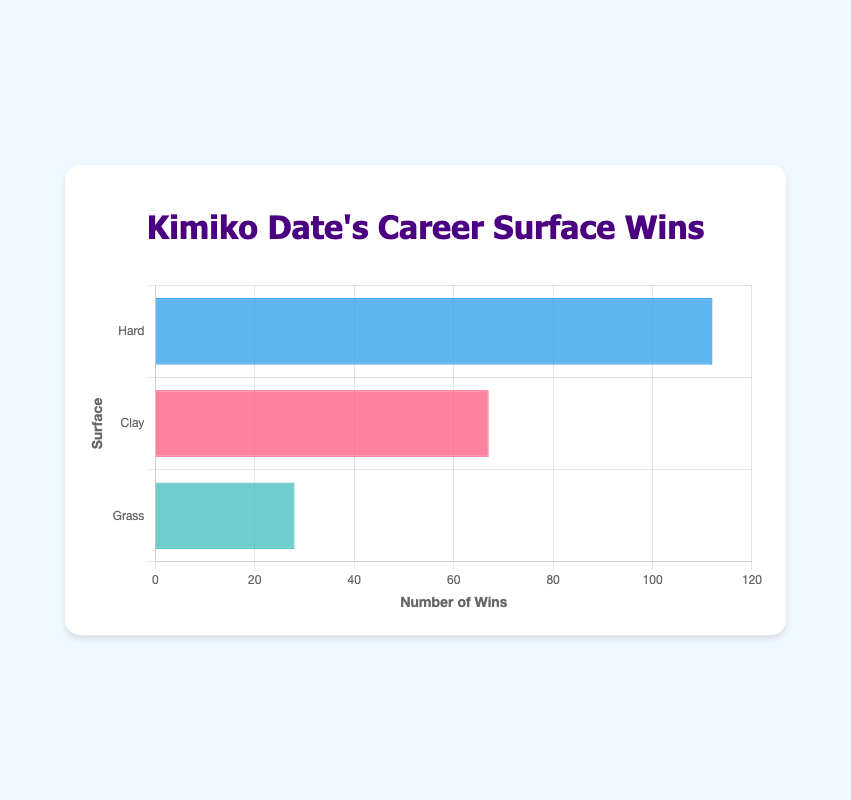What is the total number of wins across all surfaces? To find the total number of wins, add the wins from each surface: 112 (Hard) + 67 (Clay) + 28 (Grass) = 207.
Answer: 207 Which surface has the highest number of wins? By inspecting the bar lengths, the Hard surface has the most wins with 112.
Answer: Hard How many more wins does Kimiko Date have on Hard courts compared to Grass courts? Subtract the wins on Grass from the wins on Hard: 112 (Hard) - 28 (Grass) = 84.
Answer: 84 What is the difference in the number of wins between Clay and Grass surfaces? Subtract the wins on Grass from the wins on Clay: 67 (Clay) - 28 (Grass) = 39.
Answer: 39 Which surface has the shortest bar in the chart? The Grass surface bar is the shortest, indicating it has the least number of wins.
Answer: Grass What is the average number of wins across the three surfaces? Add the wins across all surfaces and divide by the number of surfaces: (112 + 67 + 28) / 3 = 207 / 3 = 69.
Answer: 69 What fraction of Kimiko Date's total wins are on Hard courts? Calculate the fraction by dividing the Hard court wins by the total wins: 112 / 207 ≈ 0.541 or approximately 54.1%.
Answer: 0.541 If Kimiko Date won 10 more matches on Clay, would it surpass the wins on Hard courts? Adding 10 to Clay wins makes it 67 + 10 = 77, which is still less than 112 (Hard), so it would not surpass Hard court wins.
Answer: No By how much does the bar for the Clay surface exceed the bar for the Grass surface? The Clay surface has 67 wins and the Grass surface has 28 wins; the difference is 67 - 28 = 39. This difference corresponds visually to the length of the bars' gap.
Answer: 39 